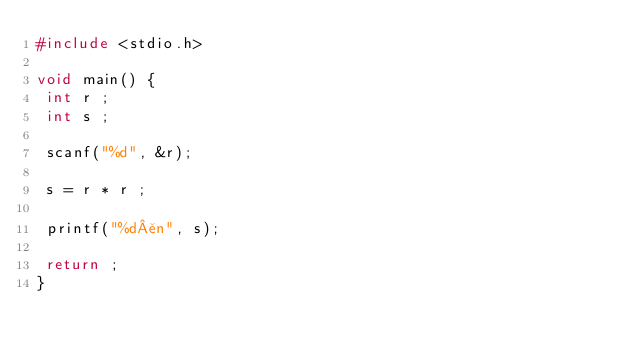<code> <loc_0><loc_0><loc_500><loc_500><_C_>#include <stdio.h>

void main() {
 int r ;
 int s ;
 
 scanf("%d", &r);
 
 s = r * r ;
 
 printf("%d¥n", s);
  
 return ;
}</code> 